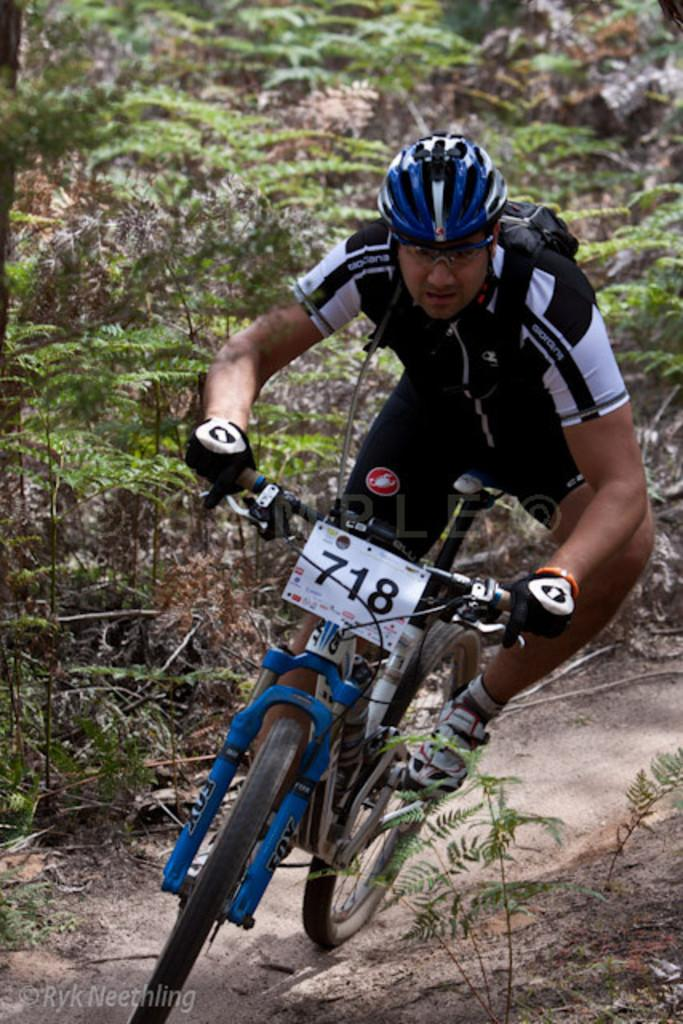What is the person in the image doing? There is a person riding a bicycle in the image. What type of surface is the person riding on? The person is riding the bicycle on land. What can be seen in the background of the image? There are plants visible in the image. How does the person in the image draw the attention of the plants? The person in the image is not interacting with the plants, so there is no indication of how they might draw their attention. 